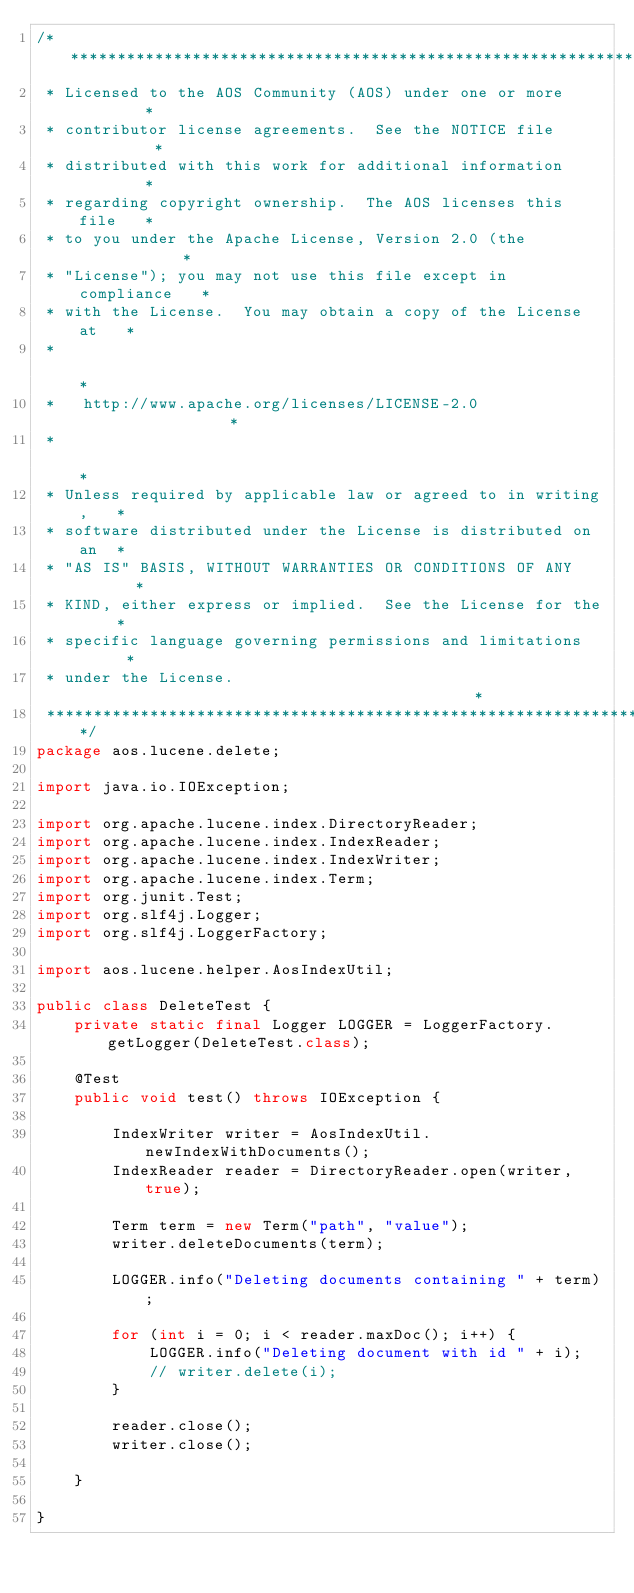Convert code to text. <code><loc_0><loc_0><loc_500><loc_500><_Java_>/****************************************************************
 * Licensed to the AOS Community (AOS) under one or more        *
 * contributor license agreements.  See the NOTICE file         *
 * distributed with this work for additional information        *
 * regarding copyright ownership.  The AOS licenses this file   *
 * to you under the Apache License, Version 2.0 (the            *
 * "License"); you may not use this file except in compliance   *
 * with the License.  You may obtain a copy of the License at   *
 *                                                              *
 *   http://www.apache.org/licenses/LICENSE-2.0                 *
 *                                                              *
 * Unless required by applicable law or agreed to in writing,   *
 * software distributed under the License is distributed on an  *
 * "AS IS" BASIS, WITHOUT WARRANTIES OR CONDITIONS OF ANY       *
 * KIND, either express or implied.  See the License for the    *
 * specific language governing permissions and limitations      *
 * under the License.                                           *
 ****************************************************************/
package aos.lucene.delete;

import java.io.IOException;

import org.apache.lucene.index.DirectoryReader;
import org.apache.lucene.index.IndexReader;
import org.apache.lucene.index.IndexWriter;
import org.apache.lucene.index.Term;
import org.junit.Test;
import org.slf4j.Logger;
import org.slf4j.LoggerFactory;

import aos.lucene.helper.AosIndexUtil;

public class DeleteTest {
    private static final Logger LOGGER = LoggerFactory.getLogger(DeleteTest.class);

    @Test
    public void test() throws IOException {

        IndexWriter writer = AosIndexUtil.newIndexWithDocuments();
        IndexReader reader = DirectoryReader.open(writer, true);

        Term term = new Term("path", "value");
        writer.deleteDocuments(term);

        LOGGER.info("Deleting documents containing " + term);

        for (int i = 0; i < reader.maxDoc(); i++) {
            LOGGER.info("Deleting document with id " + i);
            // writer.delete(i);
        }

        reader.close();
        writer.close();

    }

}
</code> 